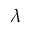Convert formula to latex. <formula><loc_0><loc_0><loc_500><loc_500>\lambda</formula> 